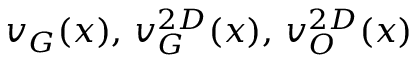<formula> <loc_0><loc_0><loc_500><loc_500>v _ { G } ( x ) , \, v _ { G } ^ { 2 D } ( x ) , \, v _ { O } ^ { 2 D } ( x )</formula> 